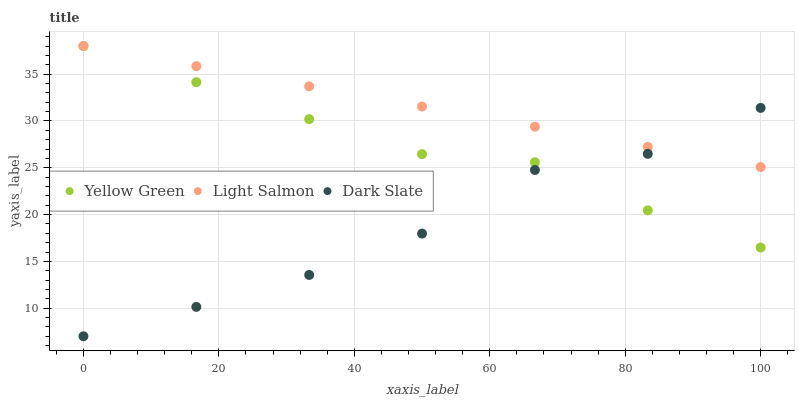Does Dark Slate have the minimum area under the curve?
Answer yes or no. Yes. Does Light Salmon have the maximum area under the curve?
Answer yes or no. Yes. Does Yellow Green have the minimum area under the curve?
Answer yes or no. No. Does Yellow Green have the maximum area under the curve?
Answer yes or no. No. Is Light Salmon the smoothest?
Answer yes or no. Yes. Is Dark Slate the roughest?
Answer yes or no. Yes. Is Yellow Green the smoothest?
Answer yes or no. No. Is Yellow Green the roughest?
Answer yes or no. No. Does Dark Slate have the lowest value?
Answer yes or no. Yes. Does Yellow Green have the lowest value?
Answer yes or no. No. Does Yellow Green have the highest value?
Answer yes or no. Yes. Does Dark Slate intersect Light Salmon?
Answer yes or no. Yes. Is Dark Slate less than Light Salmon?
Answer yes or no. No. Is Dark Slate greater than Light Salmon?
Answer yes or no. No. 